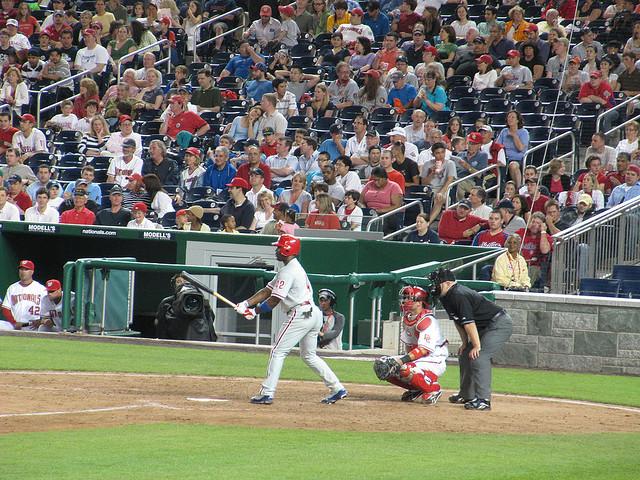Did the batter hit the ball?
Concise answer only. Yes. Are the fans standing?
Answer briefly. No. Has the batter taken a swing yet?
Quick response, please. No. What team is batting?
Quick response, please. Reds. Is the stands crowded?
Keep it brief. Yes. This baseball game is being played in what city?
Short answer required. Washington dc. 